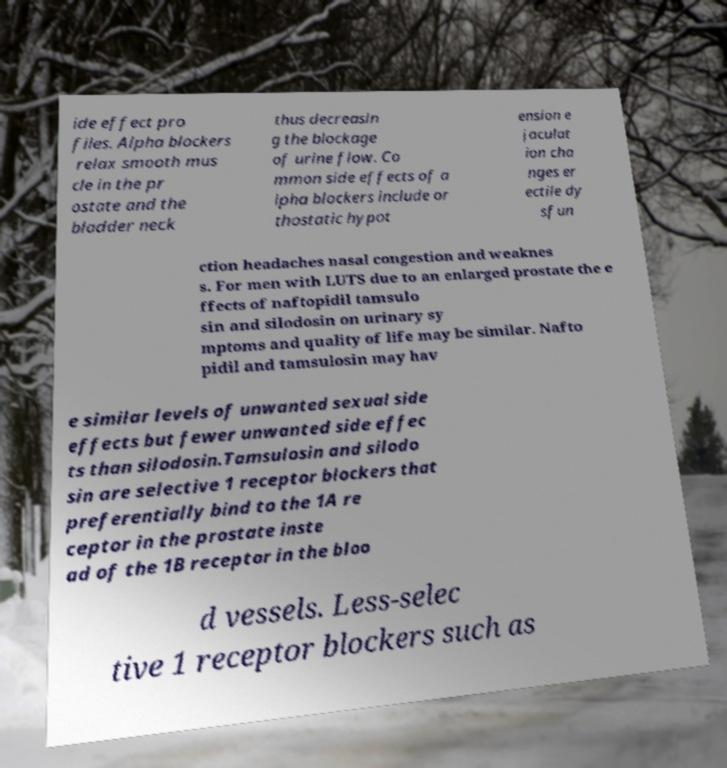Could you extract and type out the text from this image? ide effect pro files. Alpha blockers relax smooth mus cle in the pr ostate and the bladder neck thus decreasin g the blockage of urine flow. Co mmon side effects of a lpha blockers include or thostatic hypot ension e jaculat ion cha nges er ectile dy sfun ction headaches nasal congestion and weaknes s. For men with LUTS due to an enlarged prostate the e ffects of naftopidil tamsulo sin and silodosin on urinary sy mptoms and quality of life may be similar. Nafto pidil and tamsulosin may hav e similar levels of unwanted sexual side effects but fewer unwanted side effec ts than silodosin.Tamsulosin and silodo sin are selective 1 receptor blockers that preferentially bind to the 1A re ceptor in the prostate inste ad of the 1B receptor in the bloo d vessels. Less-selec tive 1 receptor blockers such as 